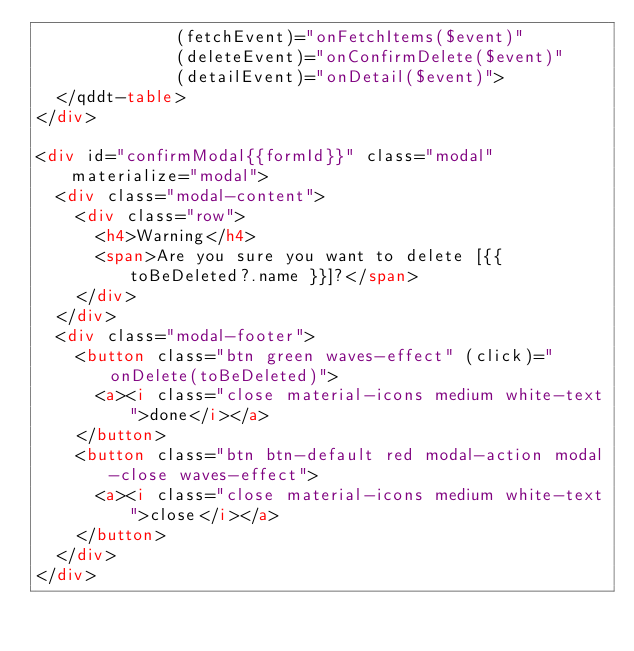<code> <loc_0><loc_0><loc_500><loc_500><_HTML_>              (fetchEvent)="onFetchItems($event)"
              (deleteEvent)="onConfirmDelete($event)"
              (detailEvent)="onDetail($event)">
  </qddt-table>
</div>

<div id="confirmModal{{formId}}" class="modal"  materialize="modal">
  <div class="modal-content">
    <div class="row">
      <h4>Warning</h4>
      <span>Are you sure you want to delete [{{ toBeDeleted?.name }}]?</span>
    </div>
  </div>
  <div class="modal-footer">
    <button class="btn green waves-effect" (click)="onDelete(toBeDeleted)">
      <a><i class="close material-icons medium white-text">done</i></a>
    </button>
    <button class="btn btn-default red modal-action modal-close waves-effect">
      <a><i class="close material-icons medium white-text">close</i></a>
    </button>
  </div>
</div>
</code> 